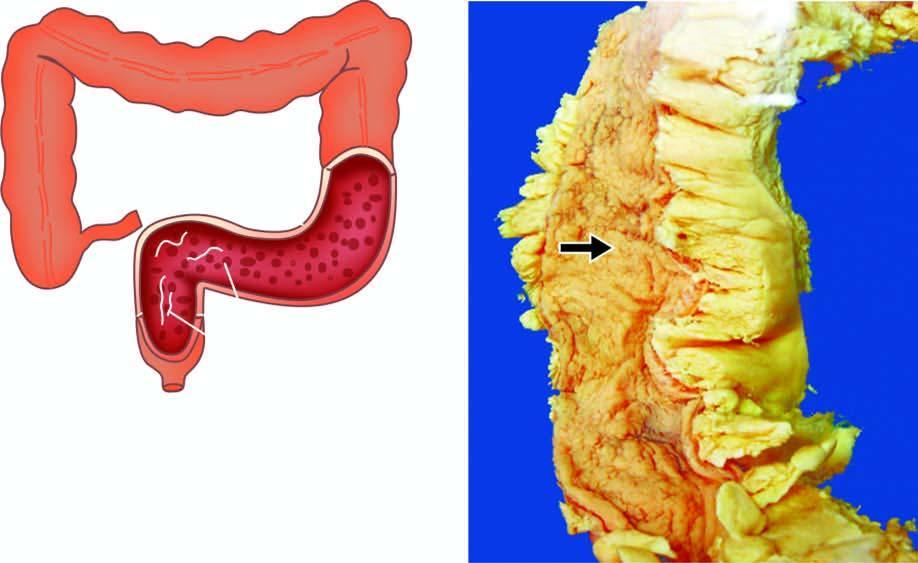s the lumen narrow?
Answer the question using a single word or phrase. Yes 